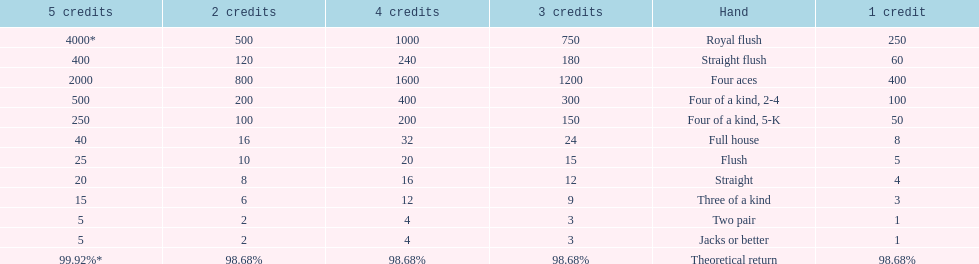Which is a higher standing hand: a straight or a flush? Flush. 